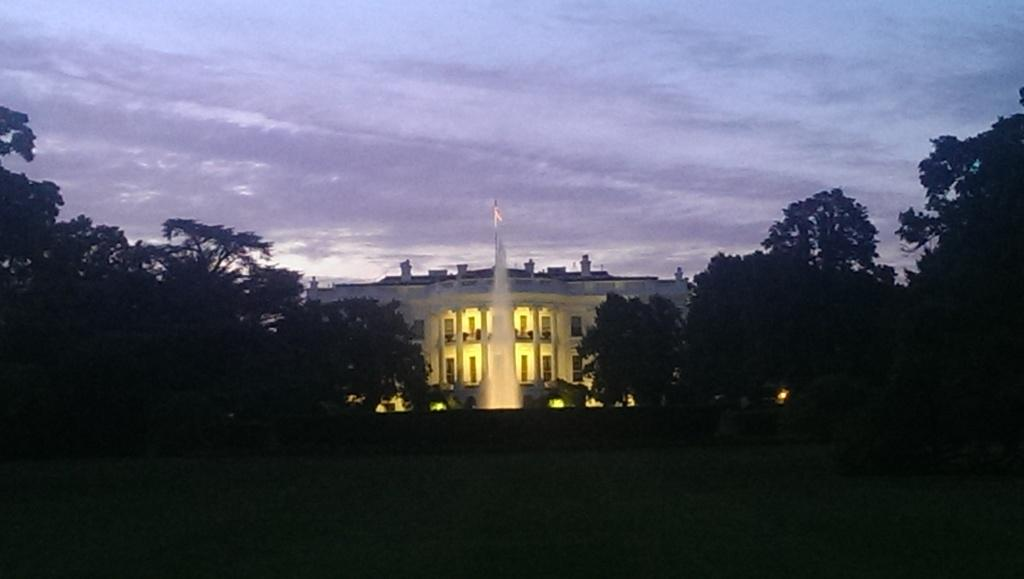What is the main feature in the image? There is a fountain in the image. What can be seen behind the fountain? There is a building behind the fountain. What type of vegetation is present around the fountain? There are trees around the fountain. How many worms can be seen crawling on the fountain in the image? There are no worms present in the image; it features a fountain, a building, and trees. What type of bird is perched on the finger of the person in the image? There is no person or bird present in the image. 